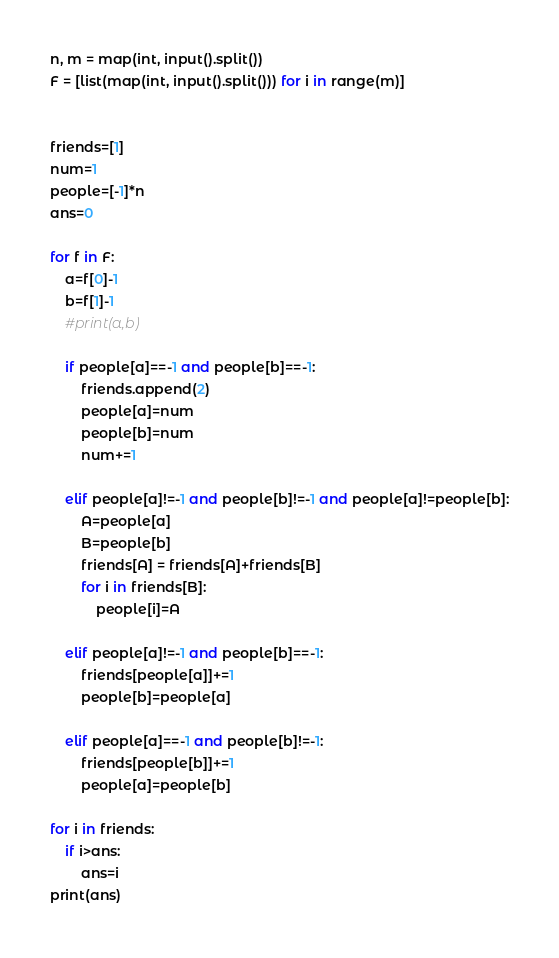<code> <loc_0><loc_0><loc_500><loc_500><_Python_>n, m = map(int, input().split())
F = [list(map(int, input().split())) for i in range(m)]


friends=[1]
num=1
people=[-1]*n
ans=0

for f in F:
    a=f[0]-1
    b=f[1]-1
    #print(a,b)

    if people[a]==-1 and people[b]==-1:
        friends.append(2)
        people[a]=num
        people[b]=num
        num+=1

    elif people[a]!=-1 and people[b]!=-1 and people[a]!=people[b]:
        A=people[a]
        B=people[b]
        friends[A] = friends[A]+friends[B]
        for i in friends[B]:
            people[i]=A

    elif people[a]!=-1 and people[b]==-1:
        friends[people[a]]+=1
        people[b]=people[a]

    elif people[a]==-1 and people[b]!=-1:
        friends[people[b]]+=1
        people[a]=people[b]

for i in friends:
    if i>ans:
        ans=i
print(ans)</code> 